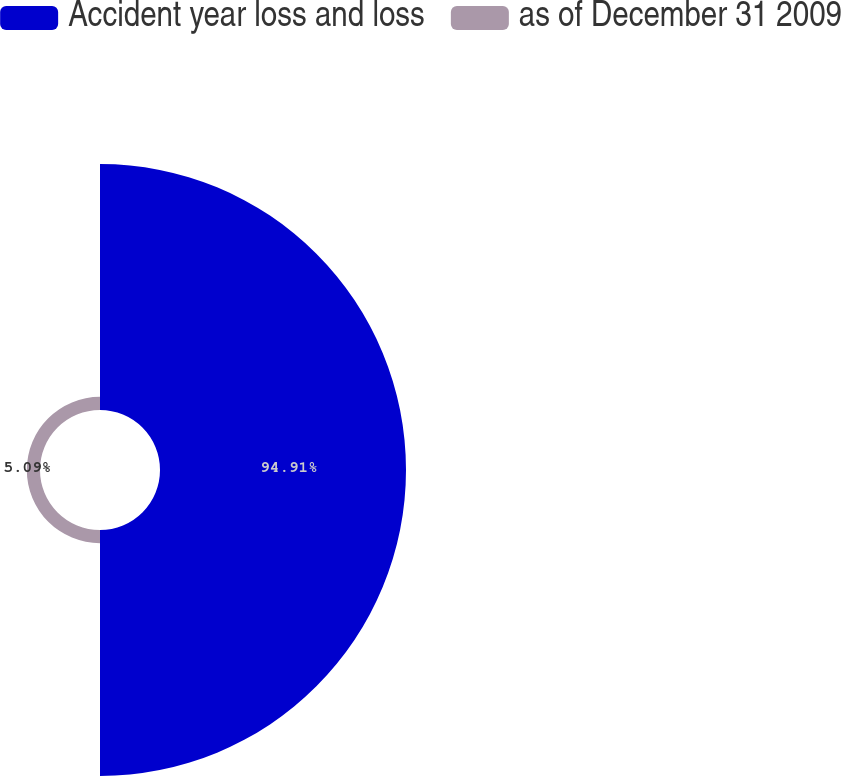<chart> <loc_0><loc_0><loc_500><loc_500><pie_chart><fcel>Accident year loss and loss<fcel>as of December 31 2009<nl><fcel>94.91%<fcel>5.09%<nl></chart> 